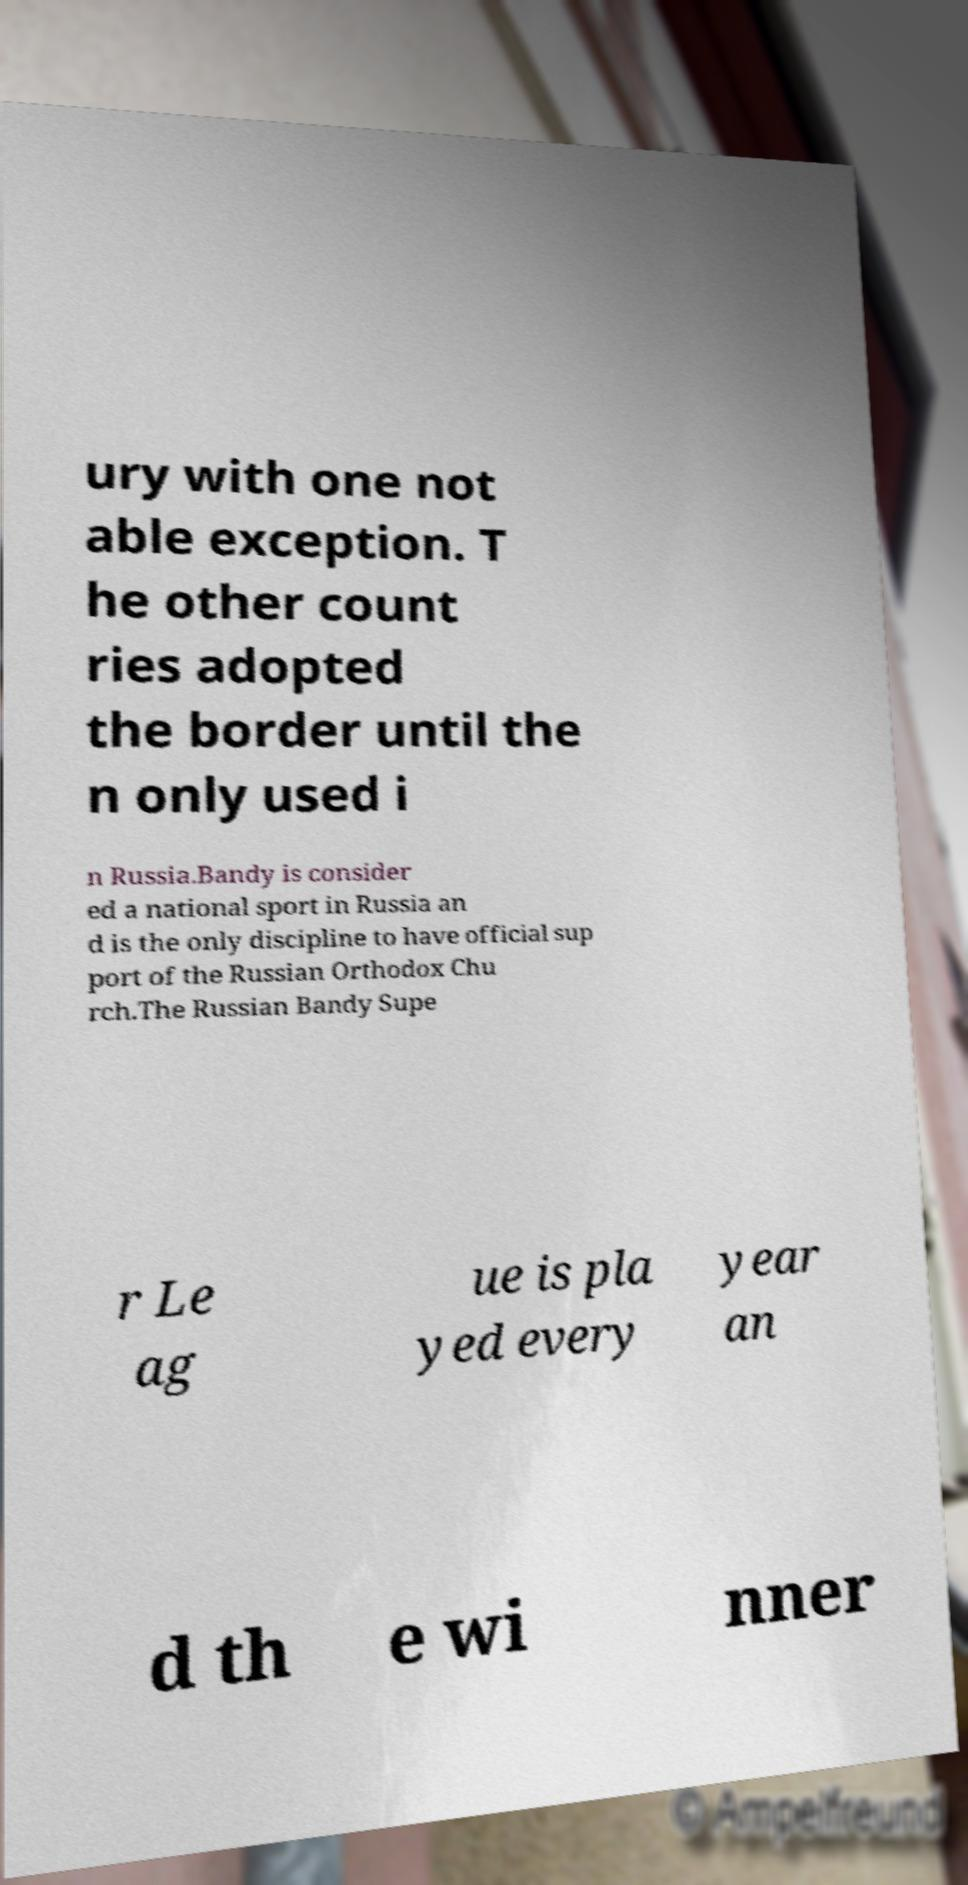Can you read and provide the text displayed in the image?This photo seems to have some interesting text. Can you extract and type it out for me? ury with one not able exception. T he other count ries adopted the border until the n only used i n Russia.Bandy is consider ed a national sport in Russia an d is the only discipline to have official sup port of the Russian Orthodox Chu rch.The Russian Bandy Supe r Le ag ue is pla yed every year an d th e wi nner 